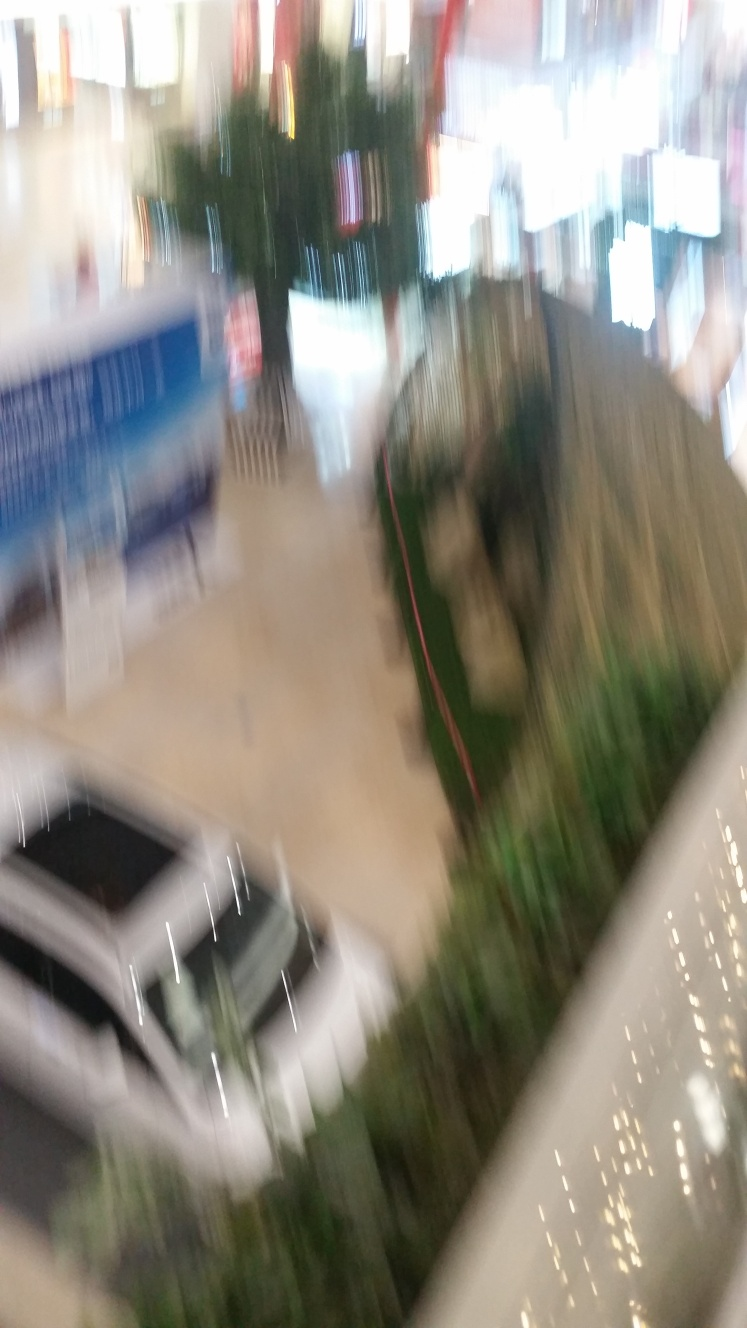Despite the motion blur, can you identify any specific elements or subjects in this image? It's tough to make out specific details due to the severe motion blur, but the general shapes suggest an indoor setting, possibly a mall or public area, with a car displayed in the center, banners hanging above, and some plant-like shapes to the right that could be part of an indoor garden or decorative plants. 